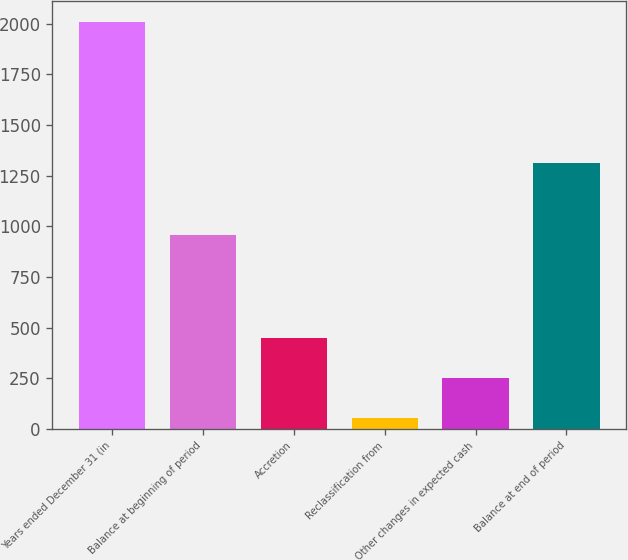<chart> <loc_0><loc_0><loc_500><loc_500><bar_chart><fcel>Years ended December 31 (in<fcel>Balance at beginning of period<fcel>Accretion<fcel>Reclassification from<fcel>Other changes in expected cash<fcel>Balance at end of period<nl><fcel>2011<fcel>954.8<fcel>446.44<fcel>55.3<fcel>250.87<fcel>1310.4<nl></chart> 